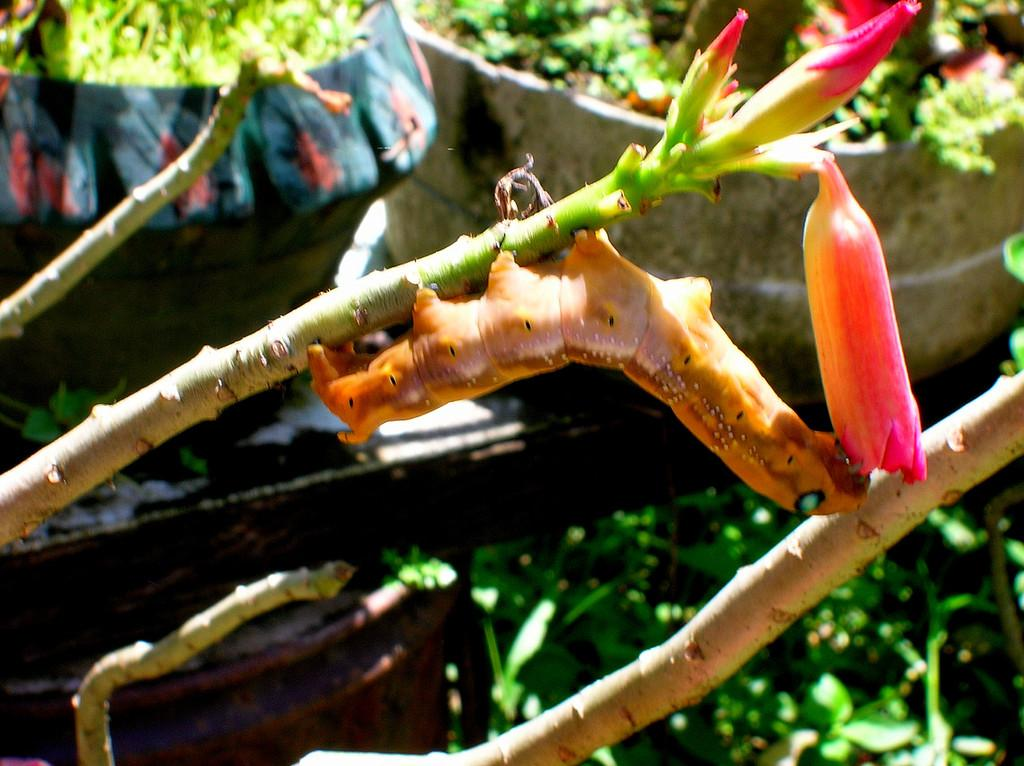What is the main subject of the image? There is a caterpillar in the image. What is the caterpillar doing in the image? The caterpillar is eating a flower. What can be seen in the background of the image? There is a flower pot in the background of the image. What type of vegetation is present at the bottom of the image? There are plants at the bottom of the image. How does the caterpillar transport itself during its trip to the flower? The image does not show the caterpillar moving or traveling to the flower; it is already eating the flower. 